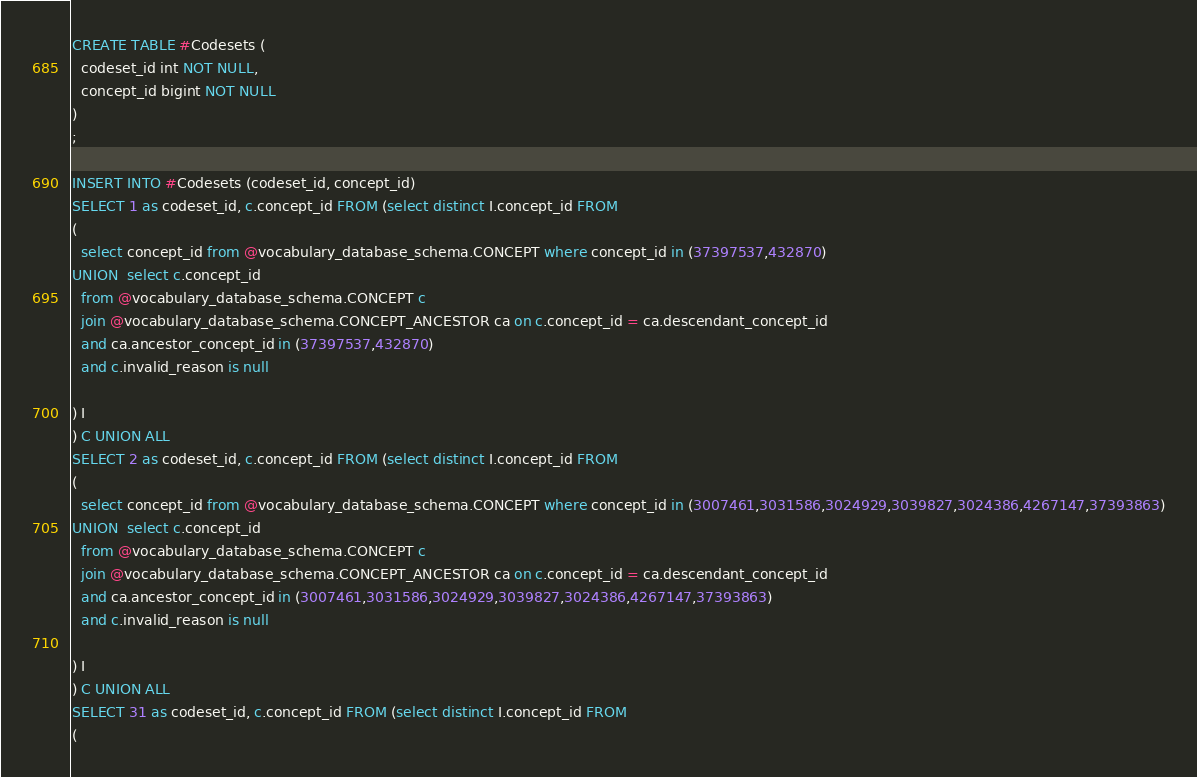Convert code to text. <code><loc_0><loc_0><loc_500><loc_500><_SQL_>CREATE TABLE #Codesets (
  codeset_id int NOT NULL,
  concept_id bigint NOT NULL
)
;

INSERT INTO #Codesets (codeset_id, concept_id)
SELECT 1 as codeset_id, c.concept_id FROM (select distinct I.concept_id FROM
( 
  select concept_id from @vocabulary_database_schema.CONCEPT where concept_id in (37397537,432870)
UNION  select c.concept_id
  from @vocabulary_database_schema.CONCEPT c
  join @vocabulary_database_schema.CONCEPT_ANCESTOR ca on c.concept_id = ca.descendant_concept_id
  and ca.ancestor_concept_id in (37397537,432870)
  and c.invalid_reason is null

) I
) C UNION ALL 
SELECT 2 as codeset_id, c.concept_id FROM (select distinct I.concept_id FROM
( 
  select concept_id from @vocabulary_database_schema.CONCEPT where concept_id in (3007461,3031586,3024929,3039827,3024386,4267147,37393863)
UNION  select c.concept_id
  from @vocabulary_database_schema.CONCEPT c
  join @vocabulary_database_schema.CONCEPT_ANCESTOR ca on c.concept_id = ca.descendant_concept_id
  and ca.ancestor_concept_id in (3007461,3031586,3024929,3039827,3024386,4267147,37393863)
  and c.invalid_reason is null

) I
) C UNION ALL 
SELECT 31 as codeset_id, c.concept_id FROM (select distinct I.concept_id FROM
( </code> 